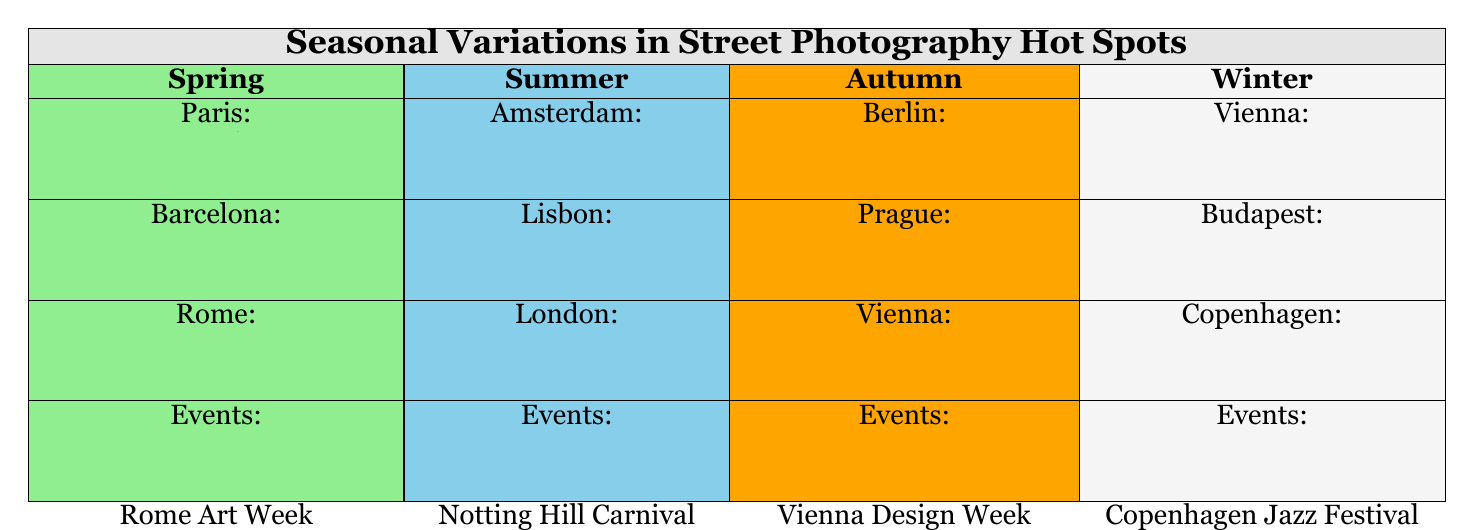What are the street photography hot spots in Paris during Spring? From the table, Paris has three hot spots listed under Spring: Champs-Élysées, Shakespeare and Company, and Montmartre.
Answer: Champs-Élysées, Shakespeare and Company, Montmartre Which city has the most hot spots listed in the Winter section? The Winter section has three cities listed: Vienna, Budapest, and Copenhagen, each with three hot spots. Therefore, no city has more; they are all equal.
Answer: None; all have the same number Are there any street photography events in Barcelona during Spring? The Spring section shows that Barcelona is listed, and it includes the event of Barcelona Primavera Sound. Therefore, yes, there is an event.
Answer: Yes Which season features events related to art in both Berlin and Vienna? The Autumn section lists Berlin Art Week for Berlin and Vienna Design Week for Vienna, indicating that both cities have art-related events during that season. Thus, the answer is Autumn.
Answer: Autumn During which season would you find hot spots in Lisbon? Referring to the Summer section, it lists Lisbon with Alfama, Bairro Alto, and Belém as its hot spots.
Answer: Summer What is the total number of distinct hot spots for street photography across all seasons? By counting all distinct hot spots: Spring has 9 (3 from each of 3 cities), Summer has 9 (3 from each of 3 cities), Autumn has 9 (3 from each of 3 cities), and Winter also has 9 (3 from each of 3 cities). Therefore, total = 9 + 9 + 9 + 9 = 36.
Answer: 36 Is Prague listed as a hot spot for winter street photography? By checking the Winter section, Prague is not listed; it's only shown in the Autumn section. Thus, the answer is no.
Answer: No Which city has a hot spot named "East Side Gallery" and in which season is it found? The table indicates that "East Side Gallery" is a hot spot in Berlin during the Autumn season.
Answer: Berlin in Autumn What is the relationship between the hot spots in Amsterdam and the events happening in Summer? Amsterdam has three hot spots in the Summer season: Jordaan, Vondelpark, Canal Ring, while the events listed are Amsterdam Open Air, indicating a vibrant cultural scene. This shows that both the hot spots and events enhance street photography opportunities in Summer.
Answer: Summer 